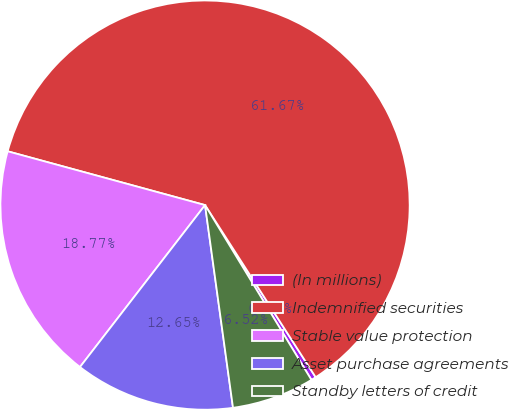<chart> <loc_0><loc_0><loc_500><loc_500><pie_chart><fcel>(In millions)<fcel>Indemnified securities<fcel>Stable value protection<fcel>Asset purchase agreements<fcel>Standby letters of credit<nl><fcel>0.39%<fcel>61.68%<fcel>18.77%<fcel>12.65%<fcel>6.52%<nl></chart> 